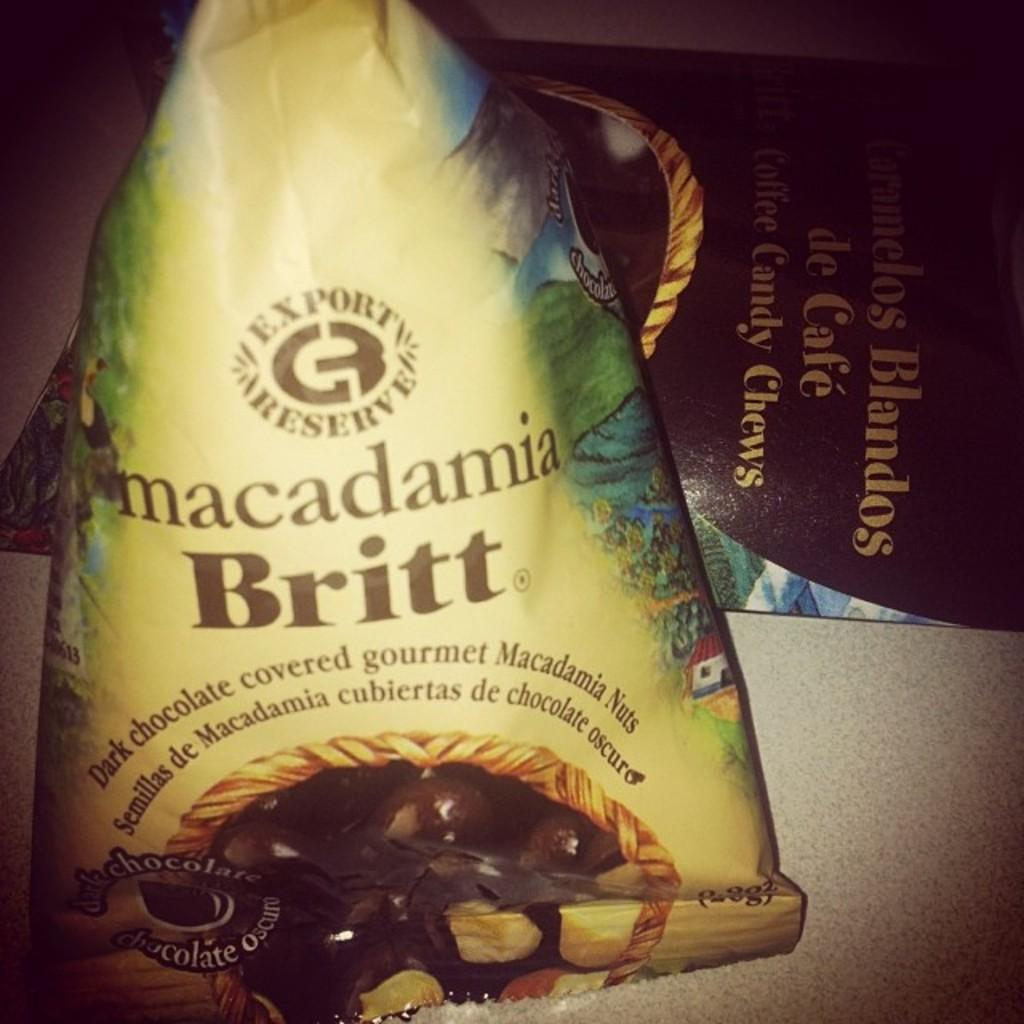<image>
Give a short and clear explanation of the subsequent image. A bag is full of dark chocolate covered macadamia nuts. 